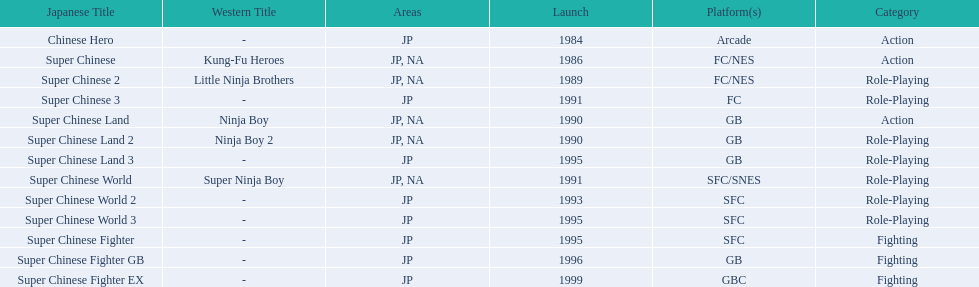Super ninja world was released in what countries? JP, NA. What was the original name for this title? Super Chinese World. 